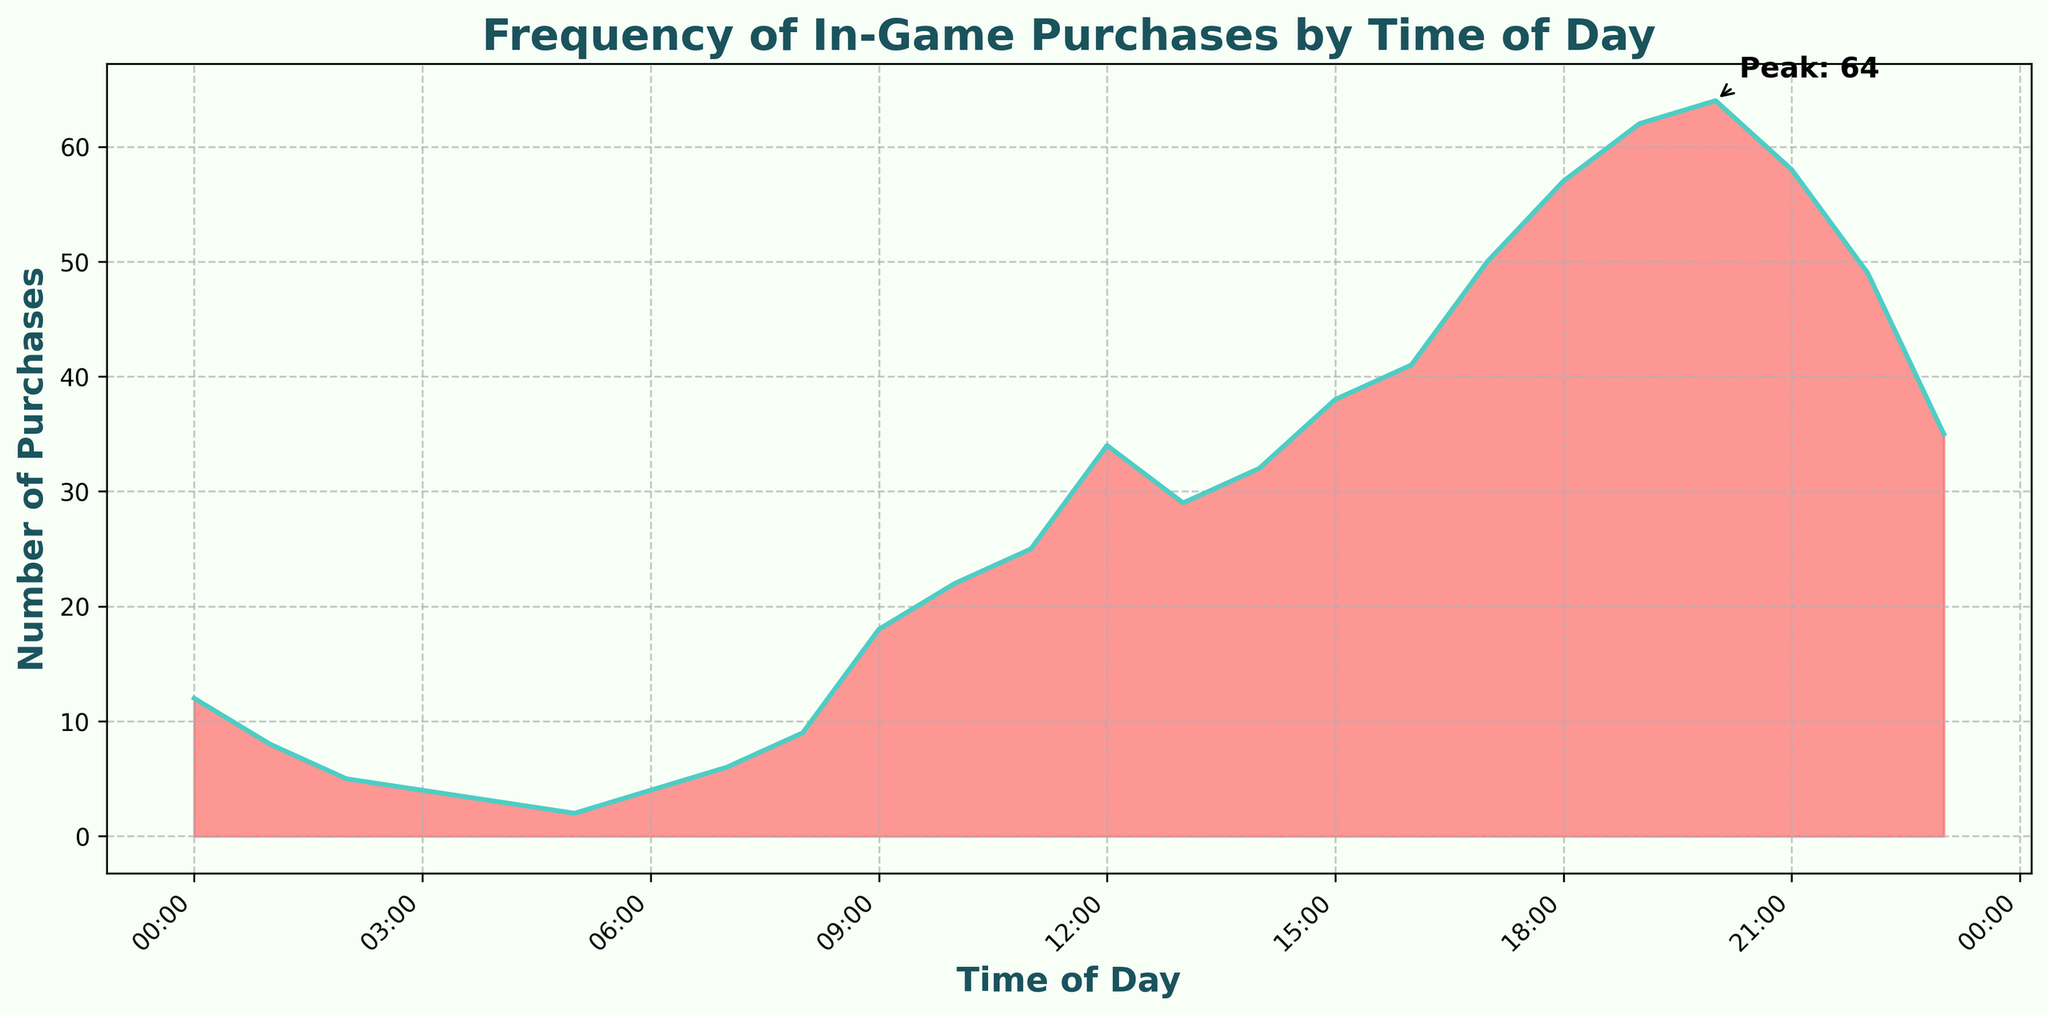What is the title of the plot? The title is usually displayed at the top center of the plot. In this case, the title is "Frequency of In-Game Purchases by Time of Day".
Answer: Frequency of In-Game Purchases by Time of Day What time has the peak of in-game purchases? The peak of in-game purchases is annotated on the plot with a label "Peak: 64". This peak is indicated by an arrow at the 20:00 time mark on the x-axis.
Answer: 20:00 What is the color used for the filled area under the curve? The filled area under the curve is colored in a shade of red with some transparency for clear visualization, specifically '#FF6B6B'.
Answer: Red How many purchases were made at 12:00? The y-axis indicates the number of purchases and the corresponding point on the curve shows about 34 purchases at 12:00.
Answer: 34 At which hour is the number of purchases equal to 41? By examining the y-axis and the corresponding points on the plot, it can be observed that at 16:00, the number of purchases matches 41.
Answer: 16:00 What is the general trend of in-game purchases throughout the day? The number of purchases starts low during the early hours (00:00 to 06:00), gradually increases from early morning (07:00) to evening (20:00), peaking at 20:00, and then slightly decreasing towards midnight.
Answer: Increases to a peak at 20:00 then decreases How many purchases were made between 08:00 and 14:00? Sum the purchases from 08:00 to 14:00: 9 (08:00) + 18 (09:00) + 22 (10:00) + 25 (11:00) + 34 (12:00) + 29 (13:00) + 32 (14:00). The total is 169.
Answer: 169 During which time period are purchases consistently below 10? From 00:00 to 08:00, the number of purchases remains below 10, indicating a relatively lower activity period.
Answer: 00:00 to 08:00 How does the number of purchases at 07:00 compare to those at 17:00? The number of purchases at 07:00 is 6, while at 17:00 it is 50. So, purchases at 17:00 are significantly higher than at 07:00.
Answer: 17:00 has more purchases 